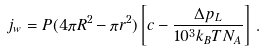Convert formula to latex. <formula><loc_0><loc_0><loc_500><loc_500>j _ { w } = P ( 4 \pi R ^ { 2 } - \pi r ^ { 2 } ) \left [ c - \frac { \Delta p _ { L } } { 1 0 ^ { 3 } k _ { B } T N _ { A } } \right ] \, .</formula> 